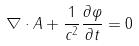Convert formula to latex. <formula><loc_0><loc_0><loc_500><loc_500>\nabla \cdot A + \frac { 1 } { c ^ { 2 } } \frac { \partial \varphi } { \partial t } = 0</formula> 